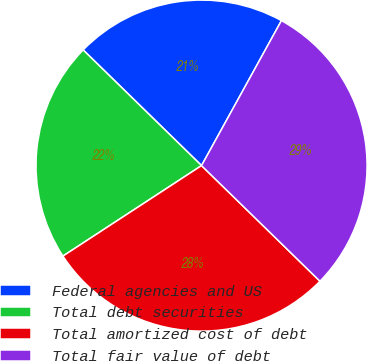Convert chart to OTSL. <chart><loc_0><loc_0><loc_500><loc_500><pie_chart><fcel>Federal agencies and US<fcel>Total debt securities<fcel>Total amortized cost of debt<fcel>Total fair value of debt<nl><fcel>20.7%<fcel>21.52%<fcel>28.48%<fcel>29.29%<nl></chart> 